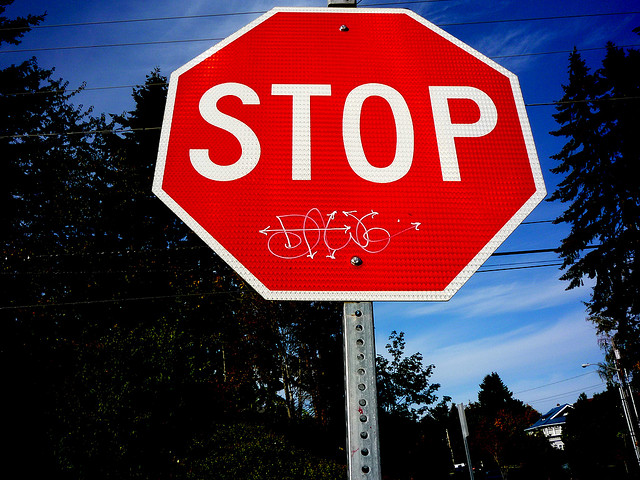<image>What does the graffiti say? I am unsure. The graffiti can say various things like 'd006', 'da66', 'dwg', 'dog', or 'do6'. What does the graffiti say? I don't know what the graffiti says. It is illegible. 